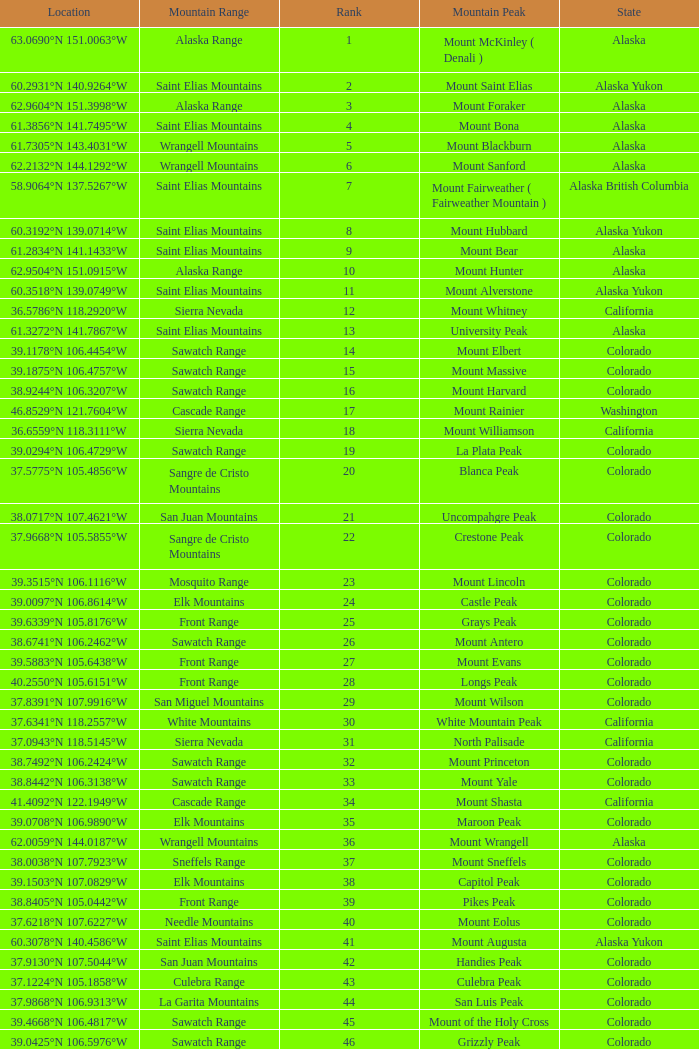What is the rank when the state is colorado and the location is 37.7859°n 107.7039°w? 83.0. 